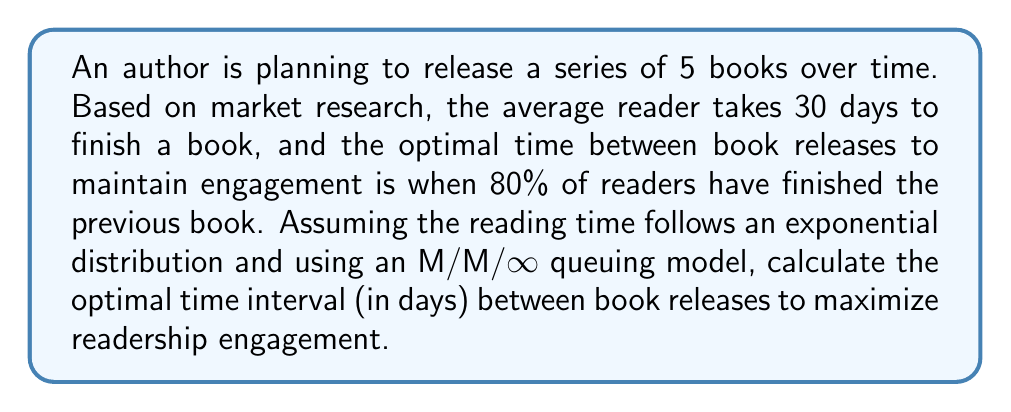Provide a solution to this math problem. Let's approach this step-by-step using queuing theory:

1) In an M/M/∞ queue, the service time (reading time) follows an exponential distribution.

2) The mean service time (μ) is 30 days.

3) For an exponential distribution, the cumulative distribution function (CDF) is:

   $F(t) = 1 - e^{-\frac{t}{\mu}}$

4) We want to find t when F(t) = 0.8 (80% of readers have finished):

   $0.8 = 1 - e^{-\frac{t}{30}}$

5) Solving for t:

   $e^{-\frac{t}{30}} = 0.2$

   $-\frac{t}{30} = \ln(0.2)$

   $t = -30 \ln(0.2)$

6) Calculate t:

   $t = -30 * (-1.60944) \approx 48.28$ days

Therefore, the optimal time interval between book releases is approximately 48 days.
Answer: 48 days 